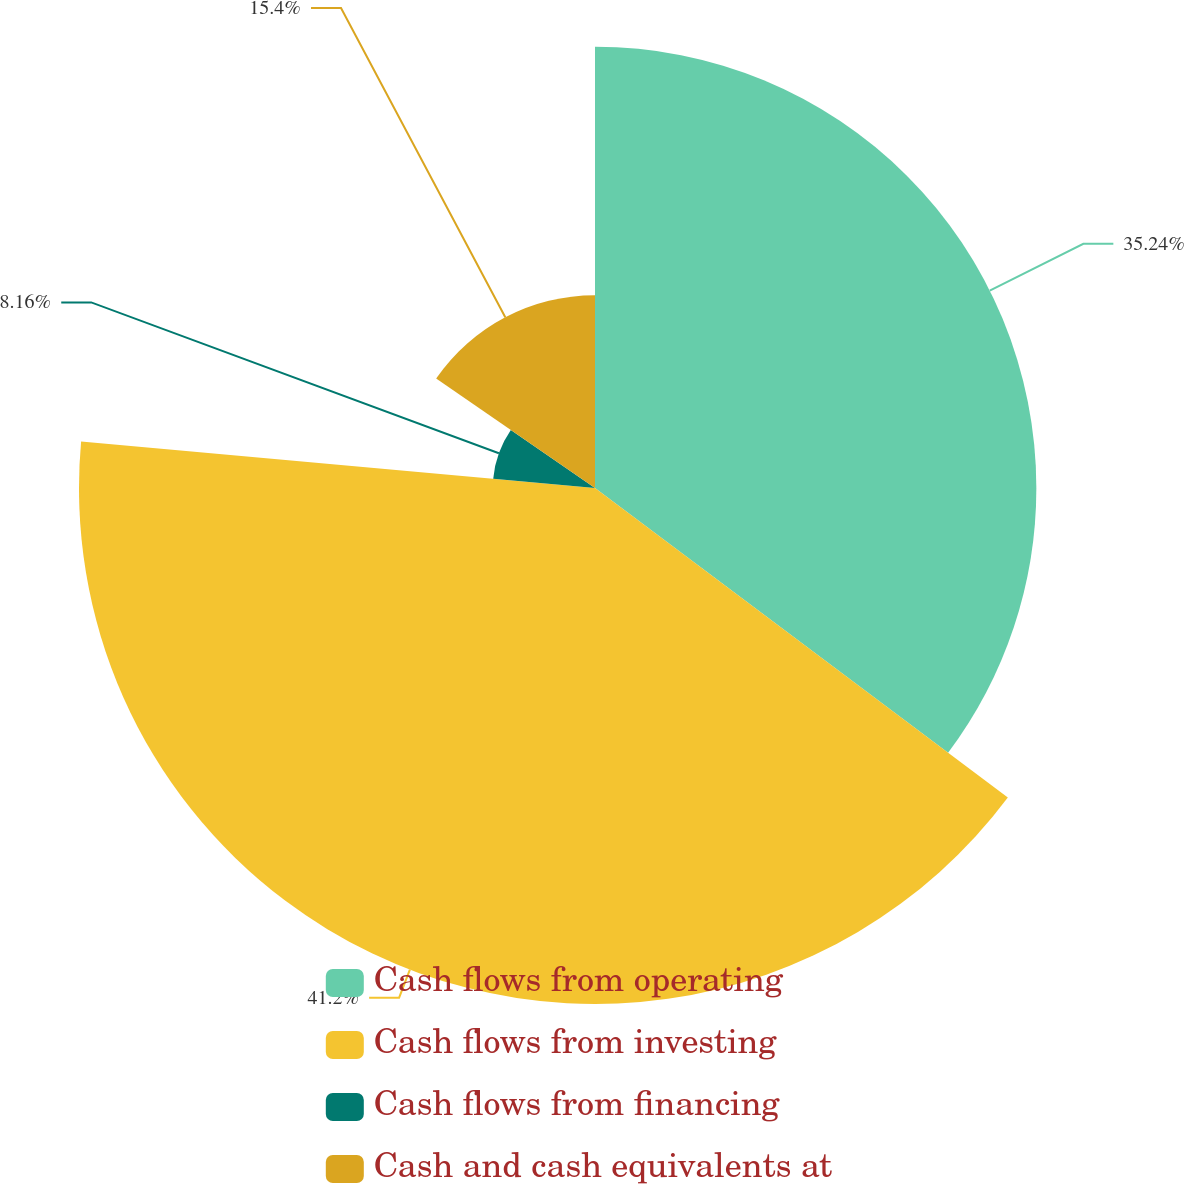Convert chart. <chart><loc_0><loc_0><loc_500><loc_500><pie_chart><fcel>Cash flows from operating<fcel>Cash flows from investing<fcel>Cash flows from financing<fcel>Cash and cash equivalents at<nl><fcel>35.24%<fcel>41.2%<fcel>8.16%<fcel>15.4%<nl></chart> 